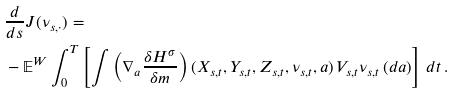Convert formula to latex. <formula><loc_0><loc_0><loc_500><loc_500>& \frac { d } { d s } J ( \nu _ { s , \cdot } ) = \\ & - \mathbb { E } ^ { W } \int _ { 0 } ^ { T } \left [ \int \left ( \nabla _ { a } \frac { \delta H ^ { \sigma } } { \delta m } \right ) ( X _ { s , t } , Y _ { s , t } , Z _ { s , t } , \nu _ { s , t } , a ) \, V _ { s , t } \nu _ { s , t } \, ( d a ) \right ] \, d t \, .</formula> 